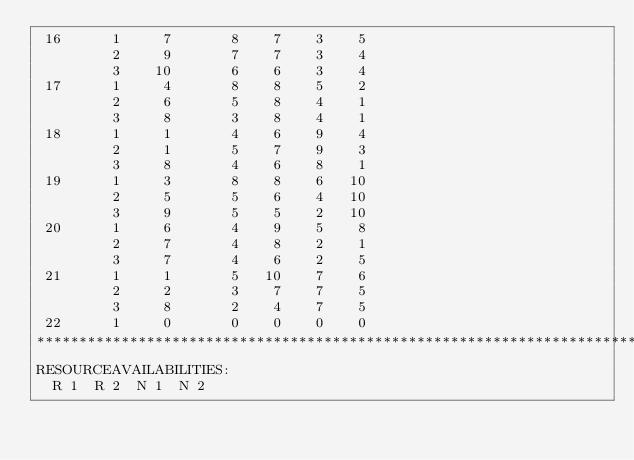Convert code to text. <code><loc_0><loc_0><loc_500><loc_500><_ObjectiveC_> 16      1     7       8    7    3    5
         2     9       7    7    3    4
         3    10       6    6    3    4
 17      1     4       8    8    5    2
         2     6       5    8    4    1
         3     8       3    8    4    1
 18      1     1       4    6    9    4
         2     1       5    7    9    3
         3     8       4    6    8    1
 19      1     3       8    8    6   10
         2     5       5    6    4   10
         3     9       5    5    2   10
 20      1     6       4    9    5    8
         2     7       4    8    2    1
         3     7       4    6    2    5
 21      1     1       5   10    7    6
         2     2       3    7    7    5
         3     8       2    4    7    5
 22      1     0       0    0    0    0
************************************************************************
RESOURCEAVAILABILITIES:
  R 1  R 2  N 1  N 2</code> 